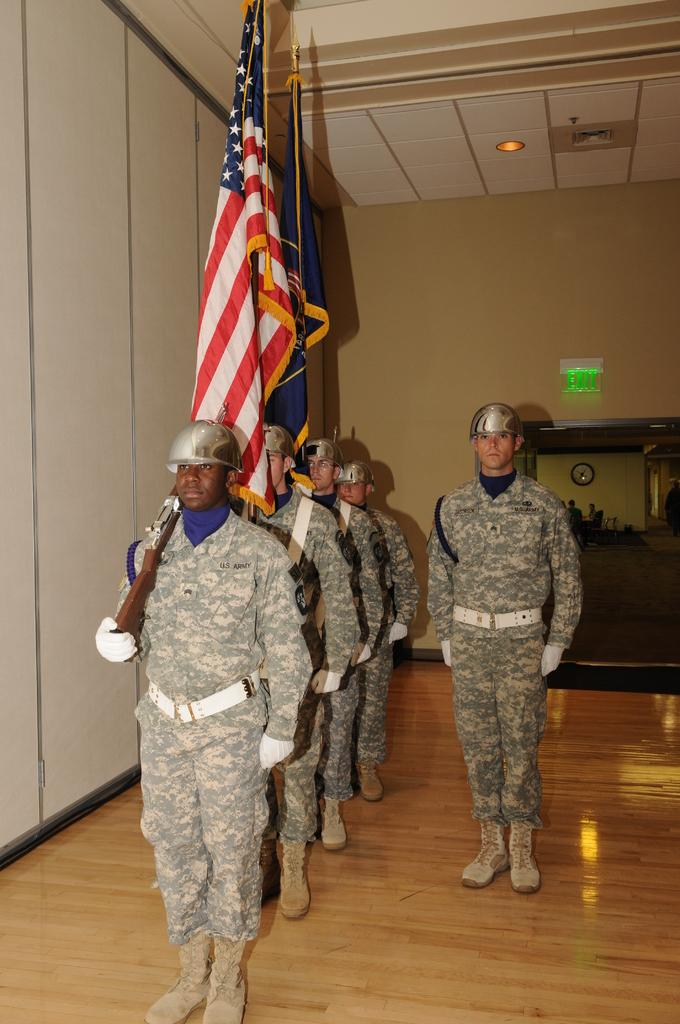What can be observed about the people in the image? There are people standing in the image, and they are wearing uniforms. What is the man in the image holding? The man in the image is holding a rifle. What can be seen in the background of the image? There are flags, a wall, and a door in the background of the image. What type of acoustics can be heard in the image? There is no information about the acoustics in the image, as it is a visual representation. Is there a crown visible on any of the people in the image? No, there is no crown visible on any of the people in the image. 